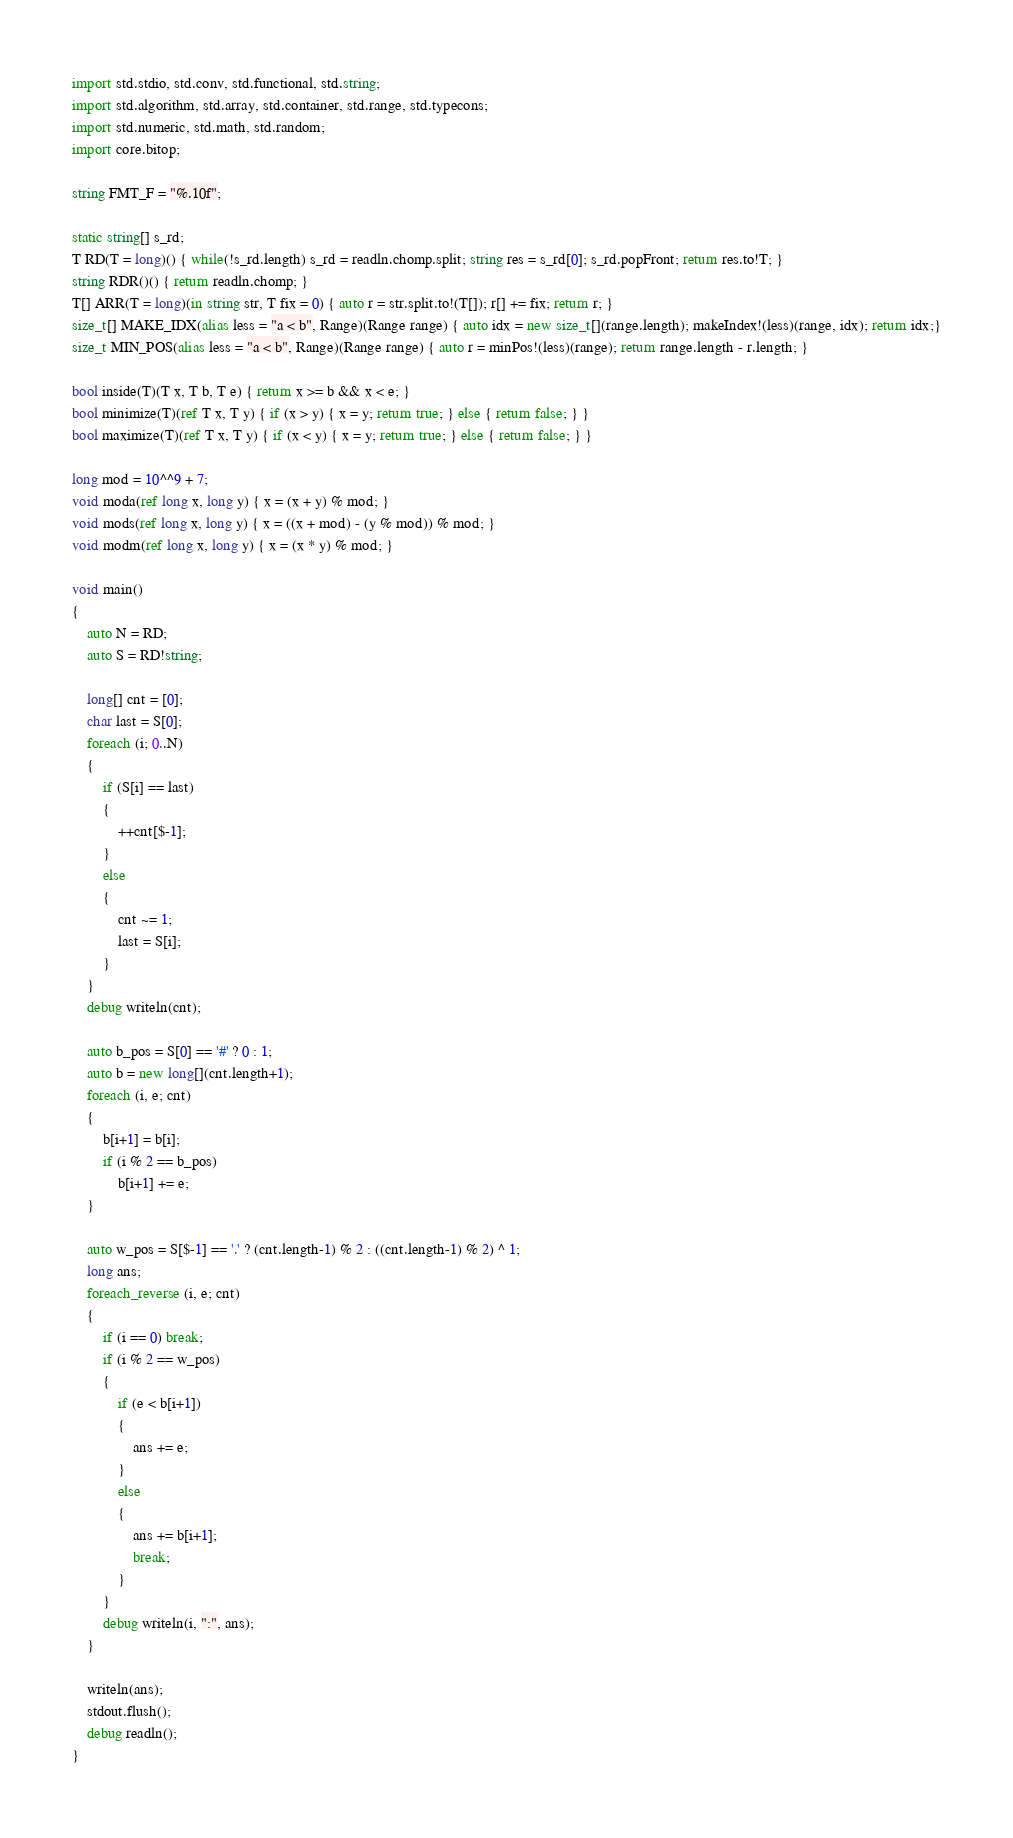Convert code to text. <code><loc_0><loc_0><loc_500><loc_500><_D_>import std.stdio, std.conv, std.functional, std.string;
import std.algorithm, std.array, std.container, std.range, std.typecons;
import std.numeric, std.math, std.random;
import core.bitop;

string FMT_F = "%.10f";

static string[] s_rd;
T RD(T = long)() { while(!s_rd.length) s_rd = readln.chomp.split; string res = s_rd[0]; s_rd.popFront; return res.to!T; }
string RDR()() { return readln.chomp; }
T[] ARR(T = long)(in string str, T fix = 0) { auto r = str.split.to!(T[]); r[] += fix; return r; }
size_t[] MAKE_IDX(alias less = "a < b", Range)(Range range) { auto idx = new size_t[](range.length); makeIndex!(less)(range, idx); return idx;}
size_t MIN_POS(alias less = "a < b", Range)(Range range) { auto r = minPos!(less)(range); return range.length - r.length; }

bool inside(T)(T x, T b, T e) { return x >= b && x < e; }
bool minimize(T)(ref T x, T y) { if (x > y) { x = y; return true; } else { return false; } }
bool maximize(T)(ref T x, T y) { if (x < y) { x = y; return true; } else { return false; } }

long mod = 10^^9 + 7;
void moda(ref long x, long y) { x = (x + y) % mod; }
void mods(ref long x, long y) { x = ((x + mod) - (y % mod)) % mod; }
void modm(ref long x, long y) { x = (x * y) % mod; }

void main()
{	
	auto N = RD;
	auto S = RD!string;

	long[] cnt = [0];
	char last = S[0];
	foreach (i; 0..N)
	{
		if (S[i] == last)
		{
			++cnt[$-1];
		}
		else
		{
			cnt ~= 1;
			last = S[i];
		}
	}
	debug writeln(cnt);

	auto b_pos = S[0] == '#' ? 0 : 1;
	auto b = new long[](cnt.length+1);
	foreach (i, e; cnt)
	{
		b[i+1] = b[i];
		if (i % 2 == b_pos)
			b[i+1] += e;
	}

	auto w_pos = S[$-1] == '.' ? (cnt.length-1) % 2 : ((cnt.length-1) % 2) ^ 1;
	long ans;
	foreach_reverse (i, e; cnt)
	{
		if (i == 0) break;
		if (i % 2 == w_pos)
		{
			if (e < b[i+1])
			{
				ans += e;
			}
			else
			{
				ans += b[i+1];
				break;
			}
		}
		debug writeln(i, ":", ans);
	}

	writeln(ans);
	stdout.flush();
	debug readln();
}</code> 